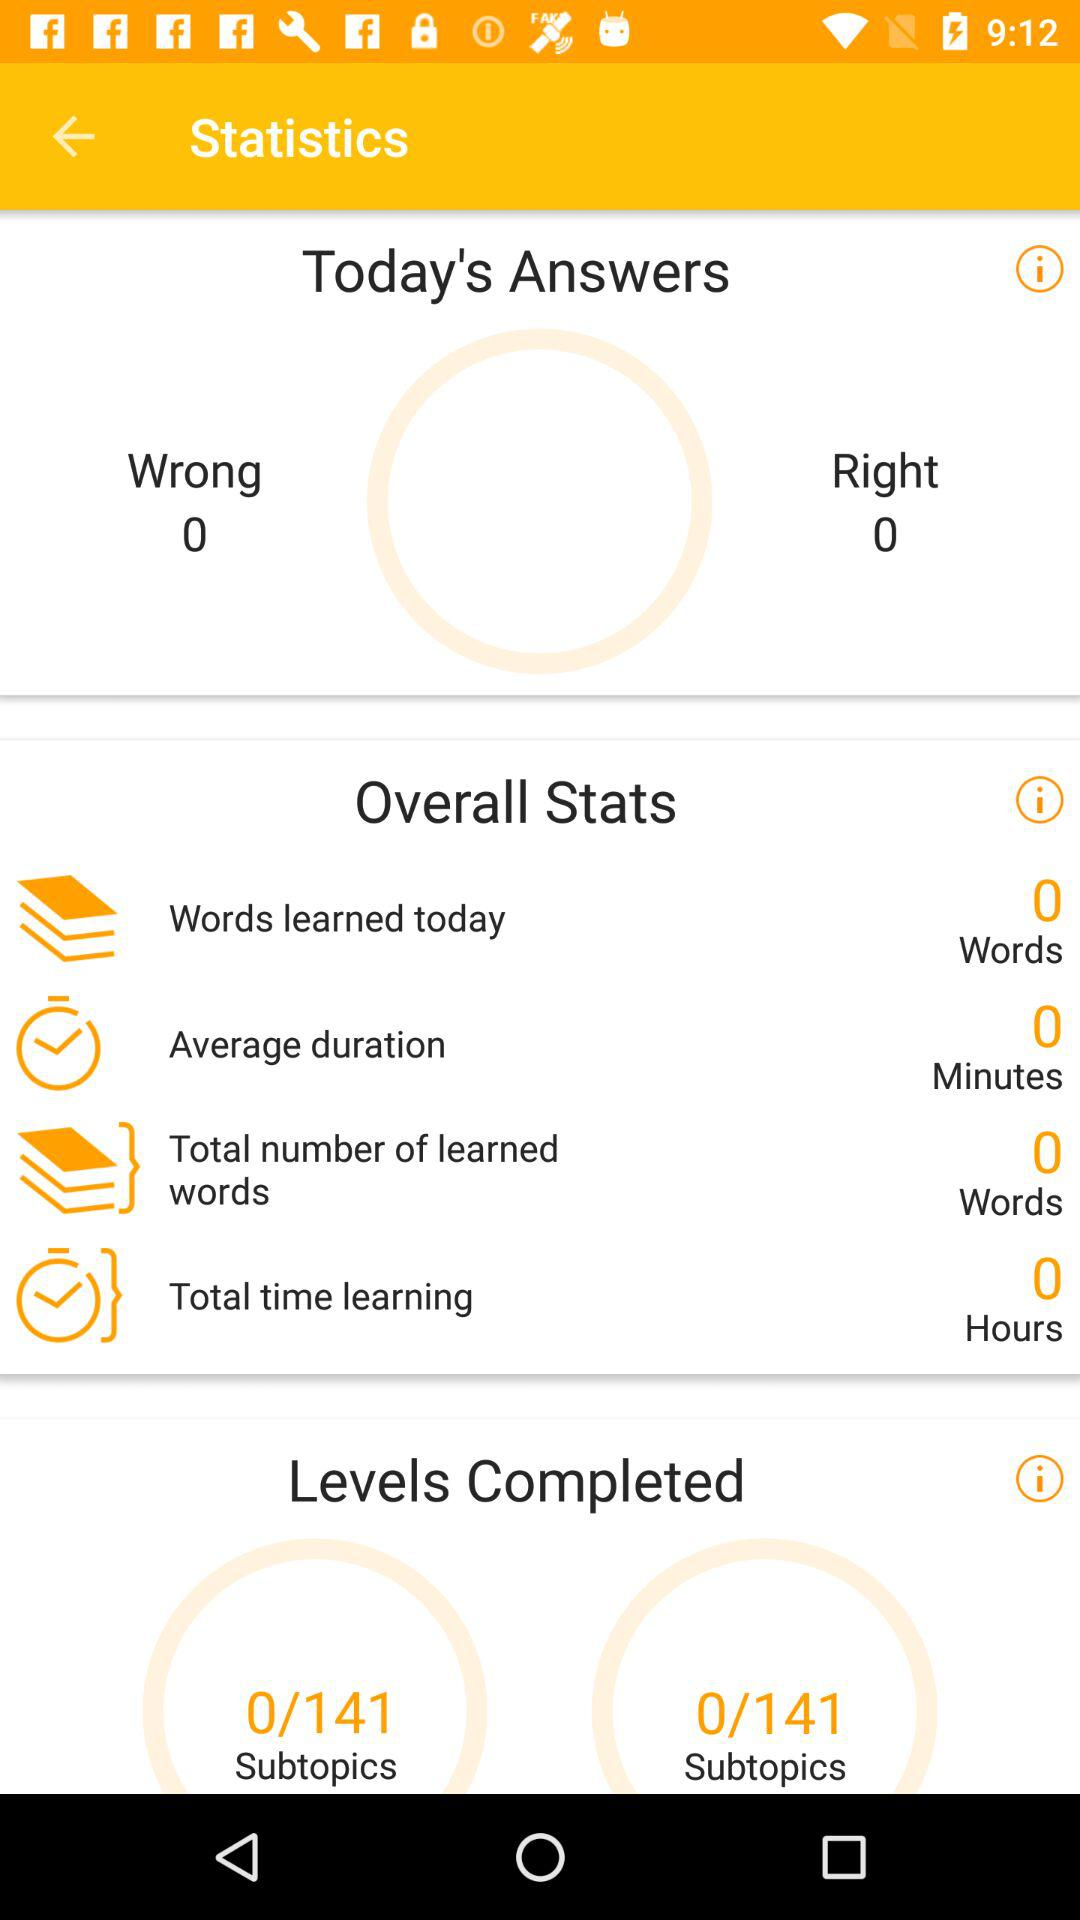What is the total number of learned words? The total number of learned words is 0. 